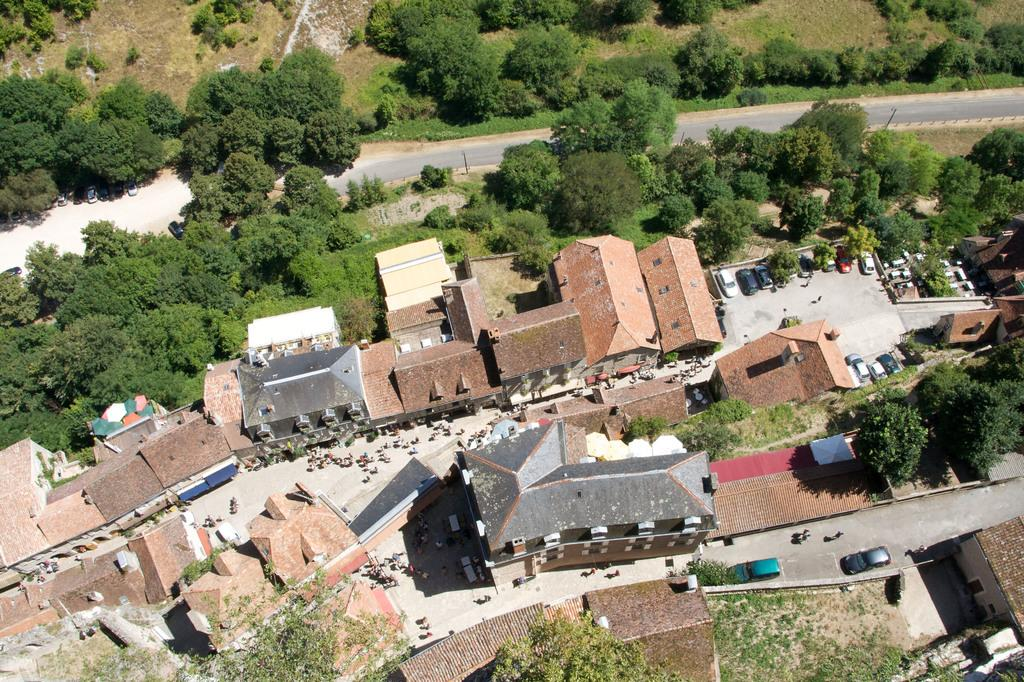What type of structures can be seen in the image? There are houses in the image. What other natural elements are present in the image? There are trees in the image. What type of man-made objects can be seen in the image? There are vehicles in the image. What are the people in the image doing? There are people walking on the road in the image. What color are the eyes of the egg in the image? There is no egg present in the image, and therefore no eyes to describe. 